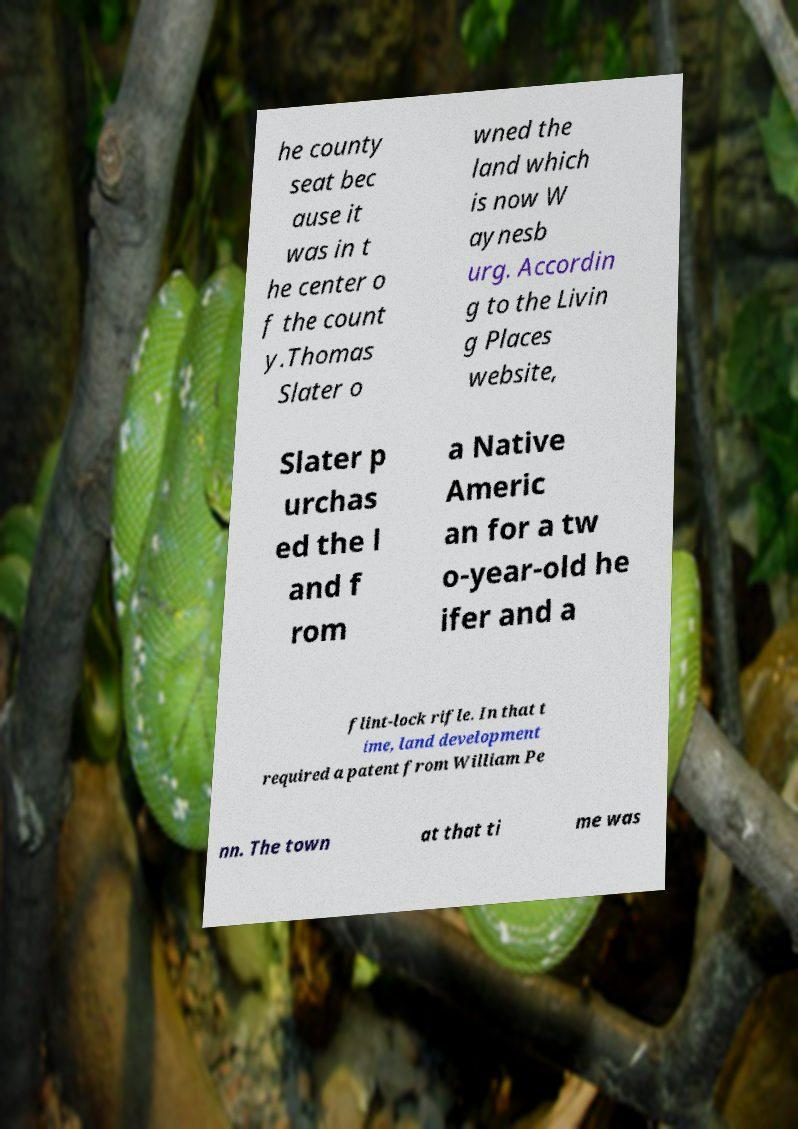What messages or text are displayed in this image? I need them in a readable, typed format. he county seat bec ause it was in t he center o f the count y.Thomas Slater o wned the land which is now W aynesb urg. Accordin g to the Livin g Places website, Slater p urchas ed the l and f rom a Native Americ an for a tw o-year-old he ifer and a flint-lock rifle. In that t ime, land development required a patent from William Pe nn. The town at that ti me was 